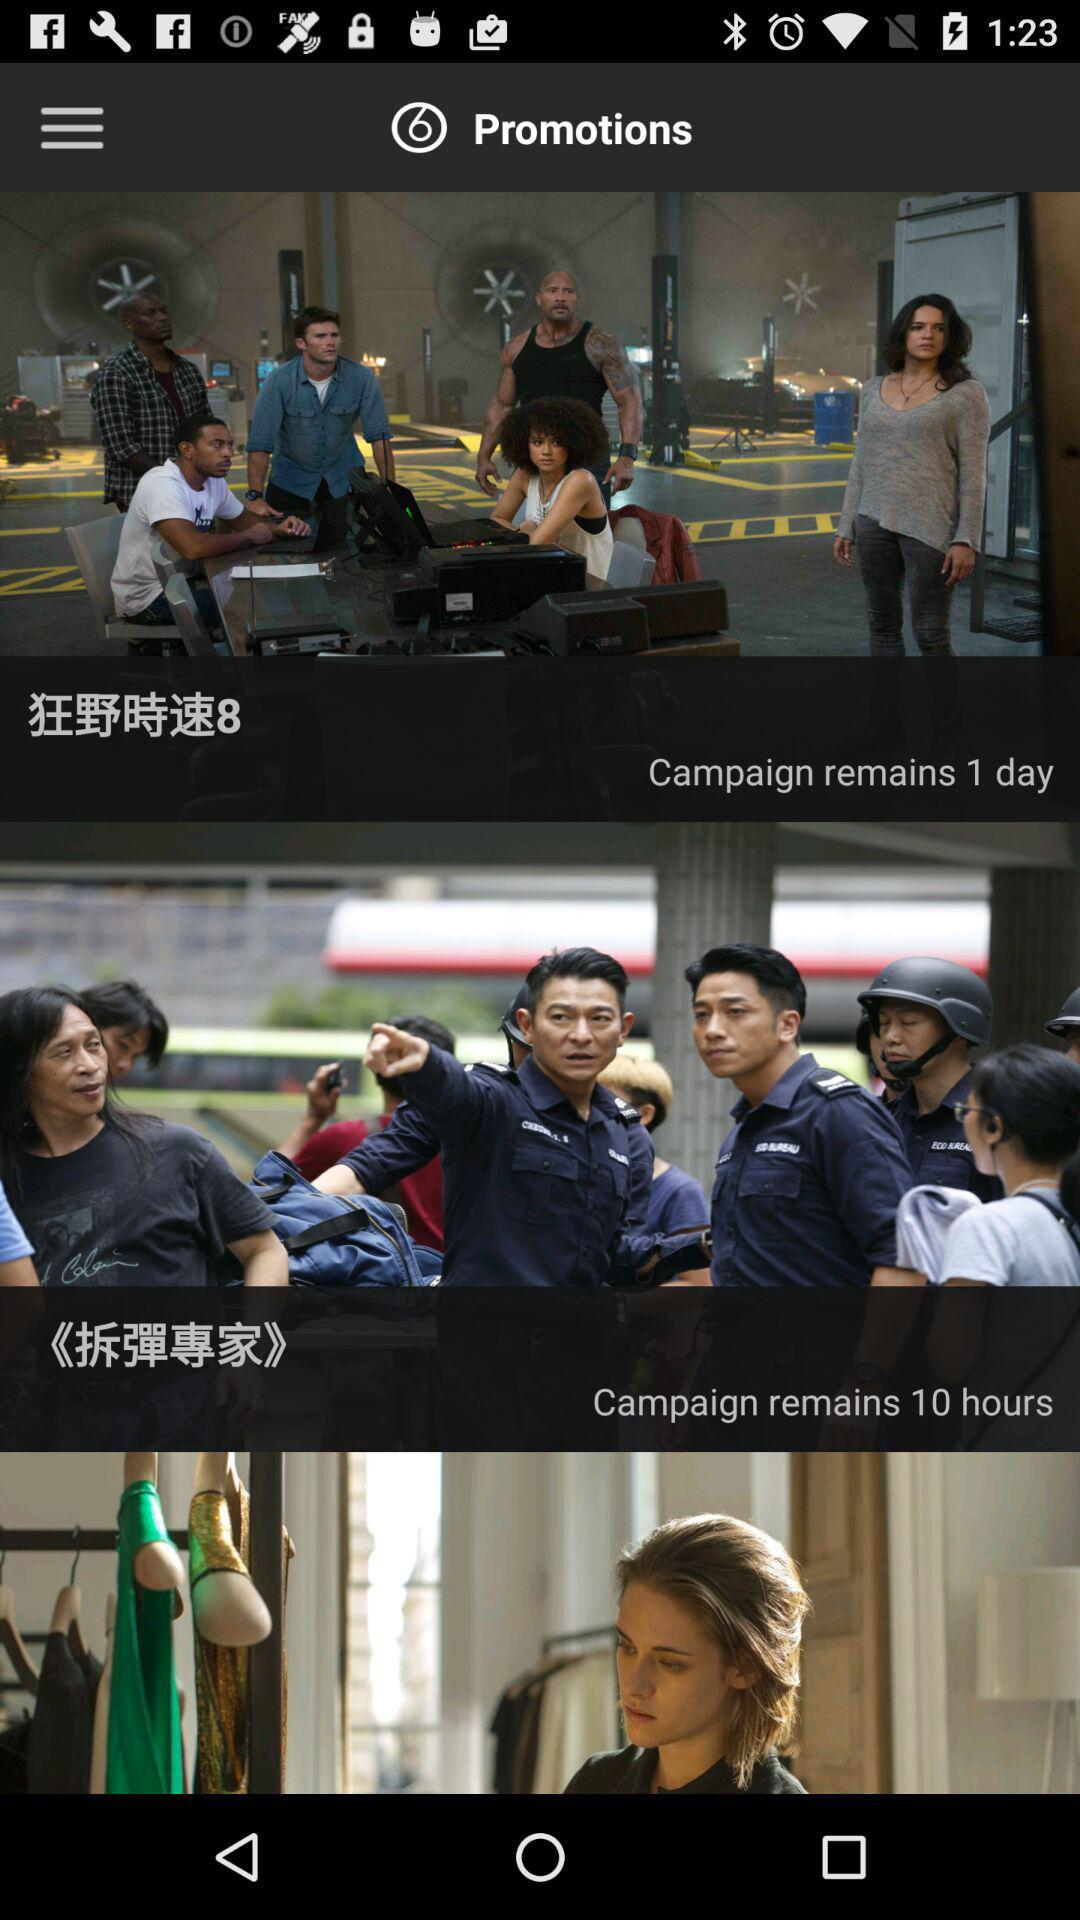How many hours of the campaign are remaining? The remaining hours of the campaign are 10. 